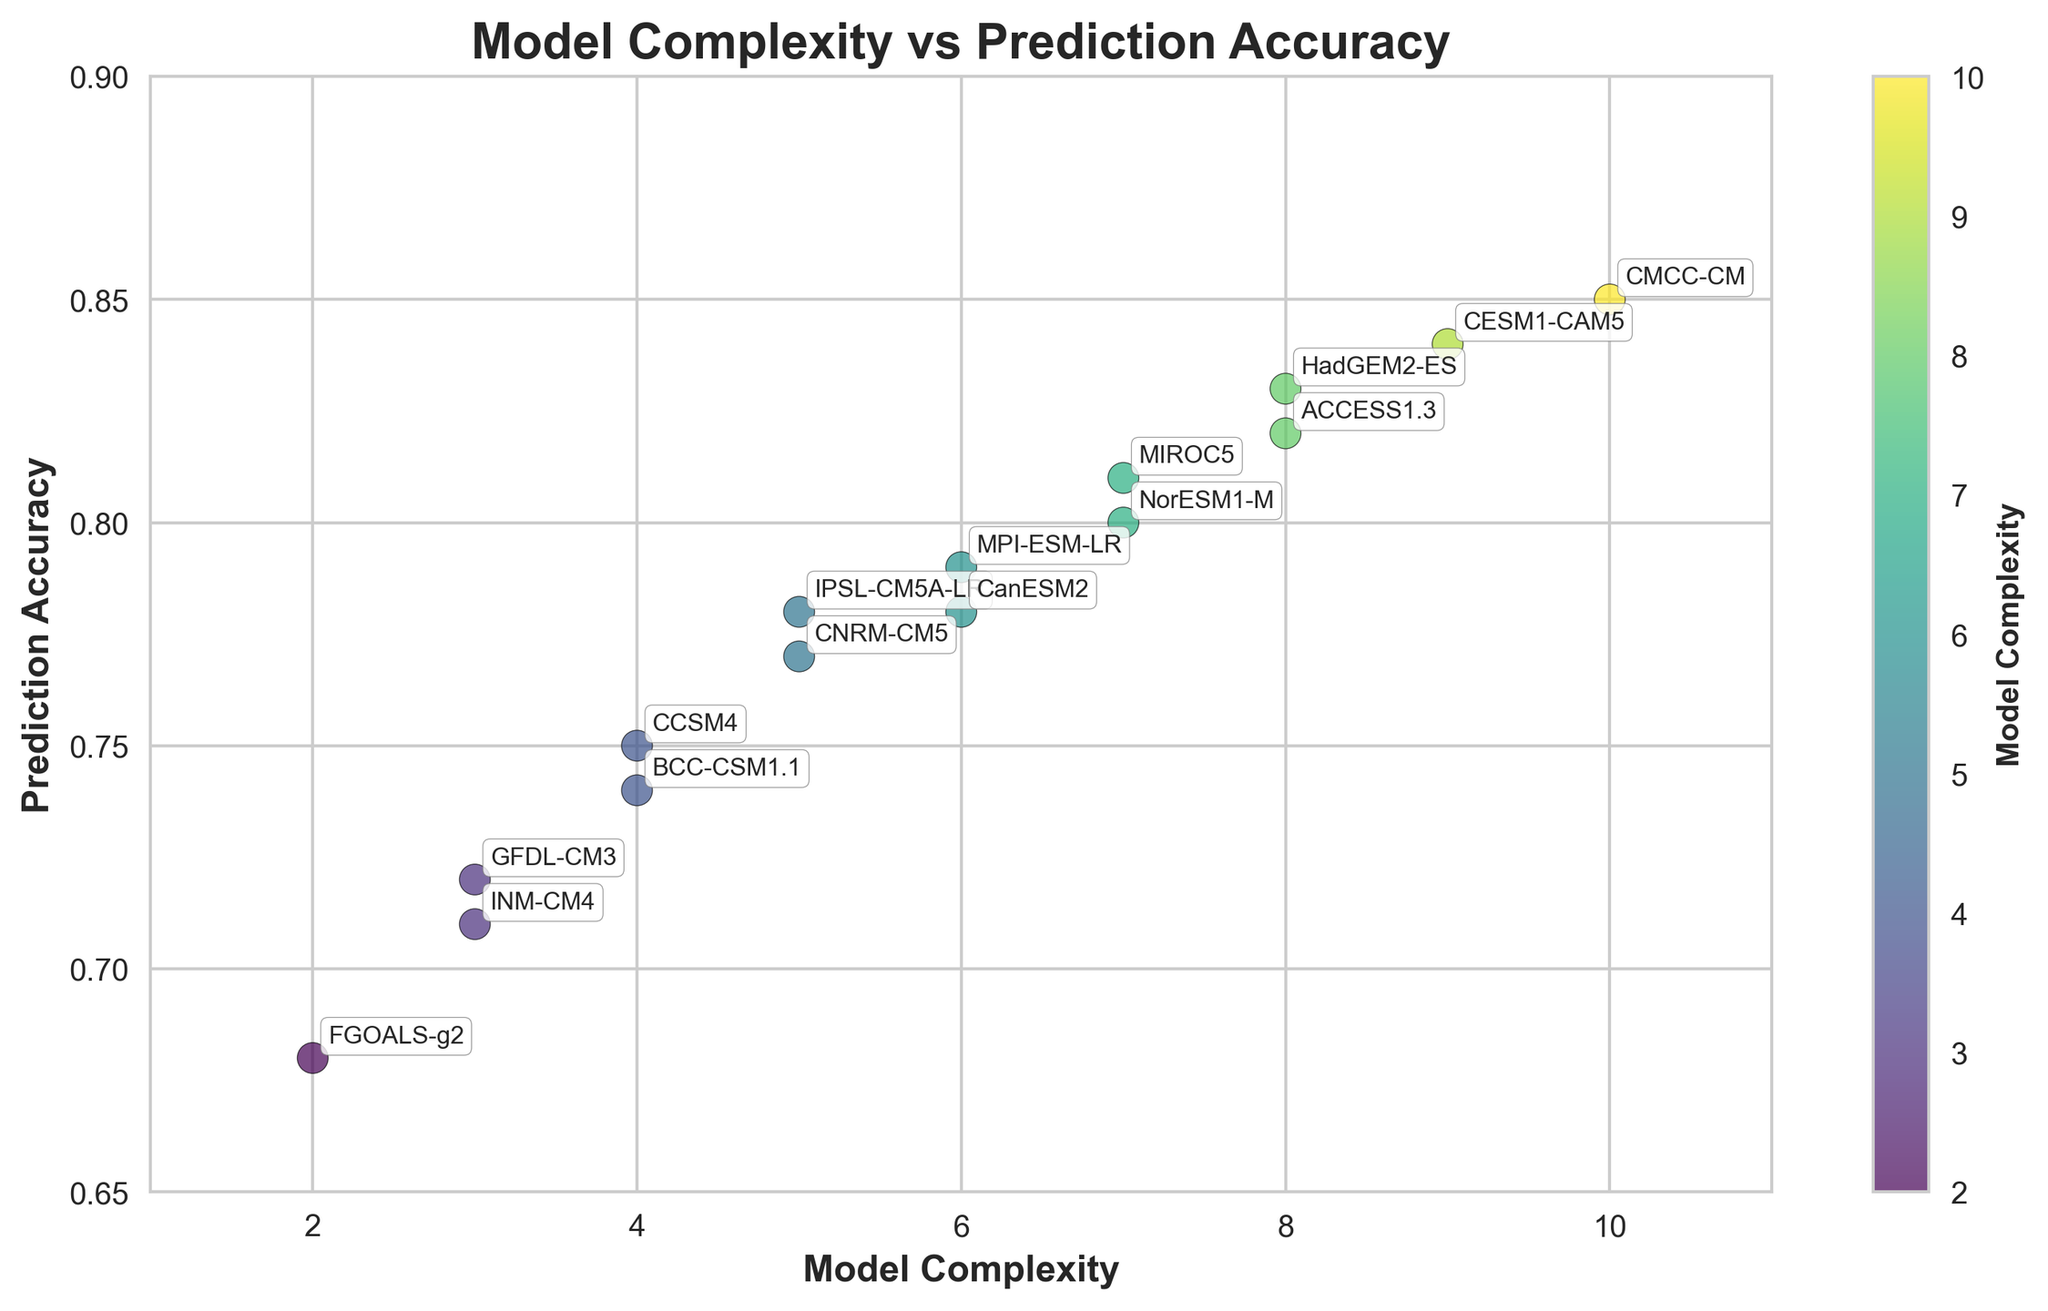What is the title of the plot? The title of the plot is displayed at the top center of the figure.
Answer: Model Complexity vs Prediction Accuracy How many climate models are shown in the scatter plot? Count the unique data points in the scatter plot.
Answer: 15 Which model has the highest prediction accuracy? Locate the data point with the highest y-axis value and identify the corresponding model.
Answer: CMCC-CM What is the accuracy difference between the models with the highest and lowest complexity? Identify the prediction accuracies of the models with the highest and lowest complexity from the plot and calculate the difference (0.85 for complexity 10 and 0.68 for complexity 2). 0.85 - 0.68 = 0.17
Answer: 0.17 Is there a general trend between model complexity and prediction accuracy? Observe the overall pattern in the scatter plot to determine if there is a positive correlation between increasing model complexity and higher prediction accuracy.
Answer: Yes, there is a positive trend Which models have a complexity of 5? Identify the data points where the x-axis value (complexity) is 5 and list the corresponding model names.
Answer: IPSL-CM5A-LR, CNRM-CM5 What is the average prediction accuracy for models with a complexity of 7? Locate the data points with complexity 7, sum their prediction accuracies and divide by the number of such data points (0.81 and 0.80, average is (0.81 + 0.80) / 2 = 0.805).
Answer: 0.805 Which model has the closest prediction accuracy to 0.80? Find the data point closest to the y-axis value of 0.80 and identify the corresponding model.
Answer: NorESM1-M How does the prediction accuracy of INM-CM4 compare to that of FGOALS-g2? Find the prediction accuracies of both models from the plot (0.71 for INM-CM4 and 0.68 for FGOALS-g2), then compare them. 0.71 > 0.68
Answer: INM-CM4 has higher accuracy What is the complexity range represented in the scatter plot? Identify the minimum and maximum values on the x-axis to determine the range of model complexity.
Answer: 2 to 10 